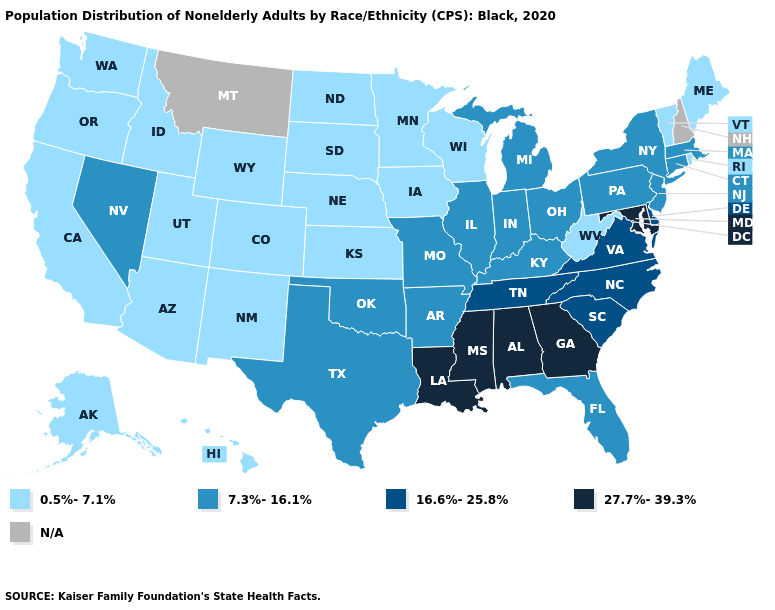Which states have the lowest value in the Northeast?
Quick response, please. Maine, Rhode Island, Vermont. Which states have the lowest value in the Northeast?
Quick response, please. Maine, Rhode Island, Vermont. Name the states that have a value in the range 7.3%-16.1%?
Short answer required. Arkansas, Connecticut, Florida, Illinois, Indiana, Kentucky, Massachusetts, Michigan, Missouri, Nevada, New Jersey, New York, Ohio, Oklahoma, Pennsylvania, Texas. Does West Virginia have the lowest value in the South?
Concise answer only. Yes. Name the states that have a value in the range 16.6%-25.8%?
Be succinct. Delaware, North Carolina, South Carolina, Tennessee, Virginia. Which states have the lowest value in the USA?
Quick response, please. Alaska, Arizona, California, Colorado, Hawaii, Idaho, Iowa, Kansas, Maine, Minnesota, Nebraska, New Mexico, North Dakota, Oregon, Rhode Island, South Dakota, Utah, Vermont, Washington, West Virginia, Wisconsin, Wyoming. Name the states that have a value in the range 27.7%-39.3%?
Quick response, please. Alabama, Georgia, Louisiana, Maryland, Mississippi. How many symbols are there in the legend?
Concise answer only. 5. Which states have the lowest value in the West?
Concise answer only. Alaska, Arizona, California, Colorado, Hawaii, Idaho, New Mexico, Oregon, Utah, Washington, Wyoming. Does New Mexico have the lowest value in the USA?
Answer briefly. Yes. Name the states that have a value in the range 27.7%-39.3%?
Give a very brief answer. Alabama, Georgia, Louisiana, Maryland, Mississippi. Name the states that have a value in the range 27.7%-39.3%?
Keep it brief. Alabama, Georgia, Louisiana, Maryland, Mississippi. Name the states that have a value in the range N/A?
Give a very brief answer. Montana, New Hampshire. What is the lowest value in the MidWest?
Concise answer only. 0.5%-7.1%. 